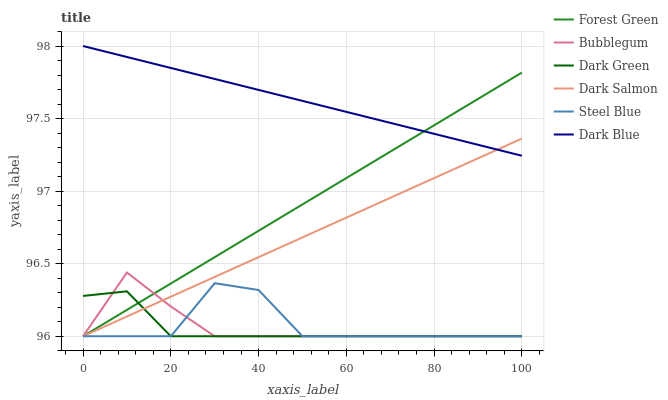Does Dark Green have the minimum area under the curve?
Answer yes or no. Yes. Does Dark Blue have the maximum area under the curve?
Answer yes or no. Yes. Does Bubblegum have the minimum area under the curve?
Answer yes or no. No. Does Bubblegum have the maximum area under the curve?
Answer yes or no. No. Is Dark Blue the smoothest?
Answer yes or no. Yes. Is Steel Blue the roughest?
Answer yes or no. Yes. Is Bubblegum the smoothest?
Answer yes or no. No. Is Bubblegum the roughest?
Answer yes or no. No. Does Steel Blue have the lowest value?
Answer yes or no. Yes. Does Dark Blue have the lowest value?
Answer yes or no. No. Does Dark Blue have the highest value?
Answer yes or no. Yes. Does Bubblegum have the highest value?
Answer yes or no. No. Is Dark Green less than Dark Blue?
Answer yes or no. Yes. Is Dark Blue greater than Steel Blue?
Answer yes or no. Yes. Does Forest Green intersect Steel Blue?
Answer yes or no. Yes. Is Forest Green less than Steel Blue?
Answer yes or no. No. Is Forest Green greater than Steel Blue?
Answer yes or no. No. Does Dark Green intersect Dark Blue?
Answer yes or no. No. 